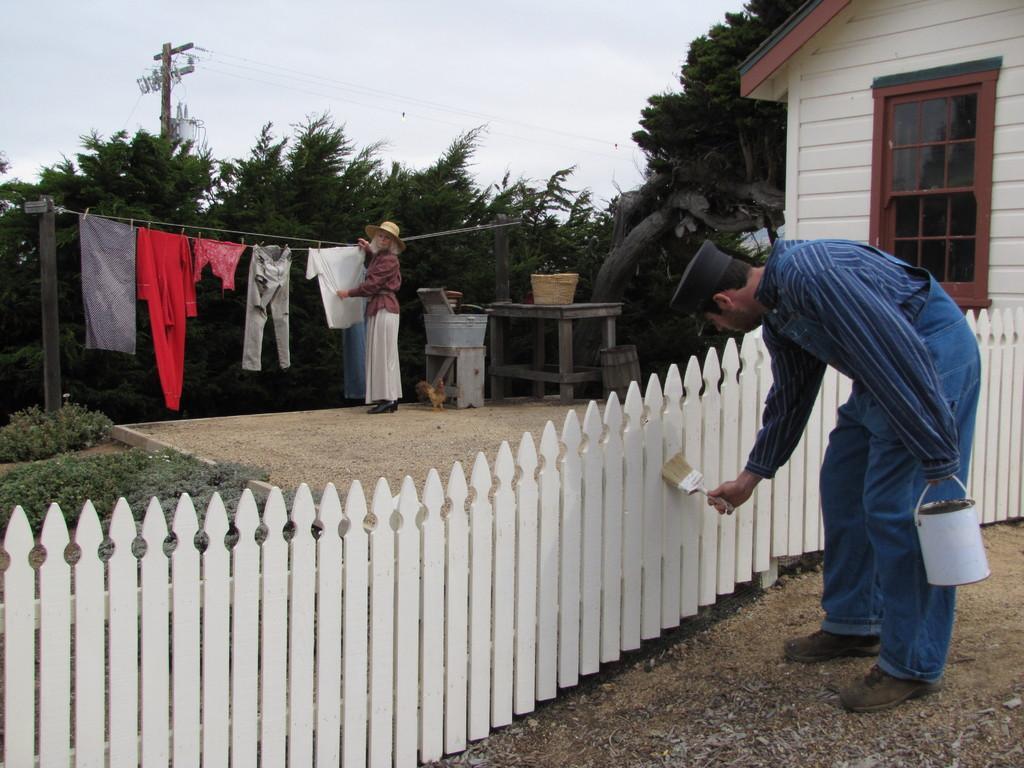How would you summarize this image in a sentence or two? In this image on the right a man wearing blue shirt is painting the fence. He is holding a painting rush and a bucket. Here there is a lady holding a cloth. Here there are clothes on the string. This is a table. In the background there are trees,building, electric pole. The sky is clear. 